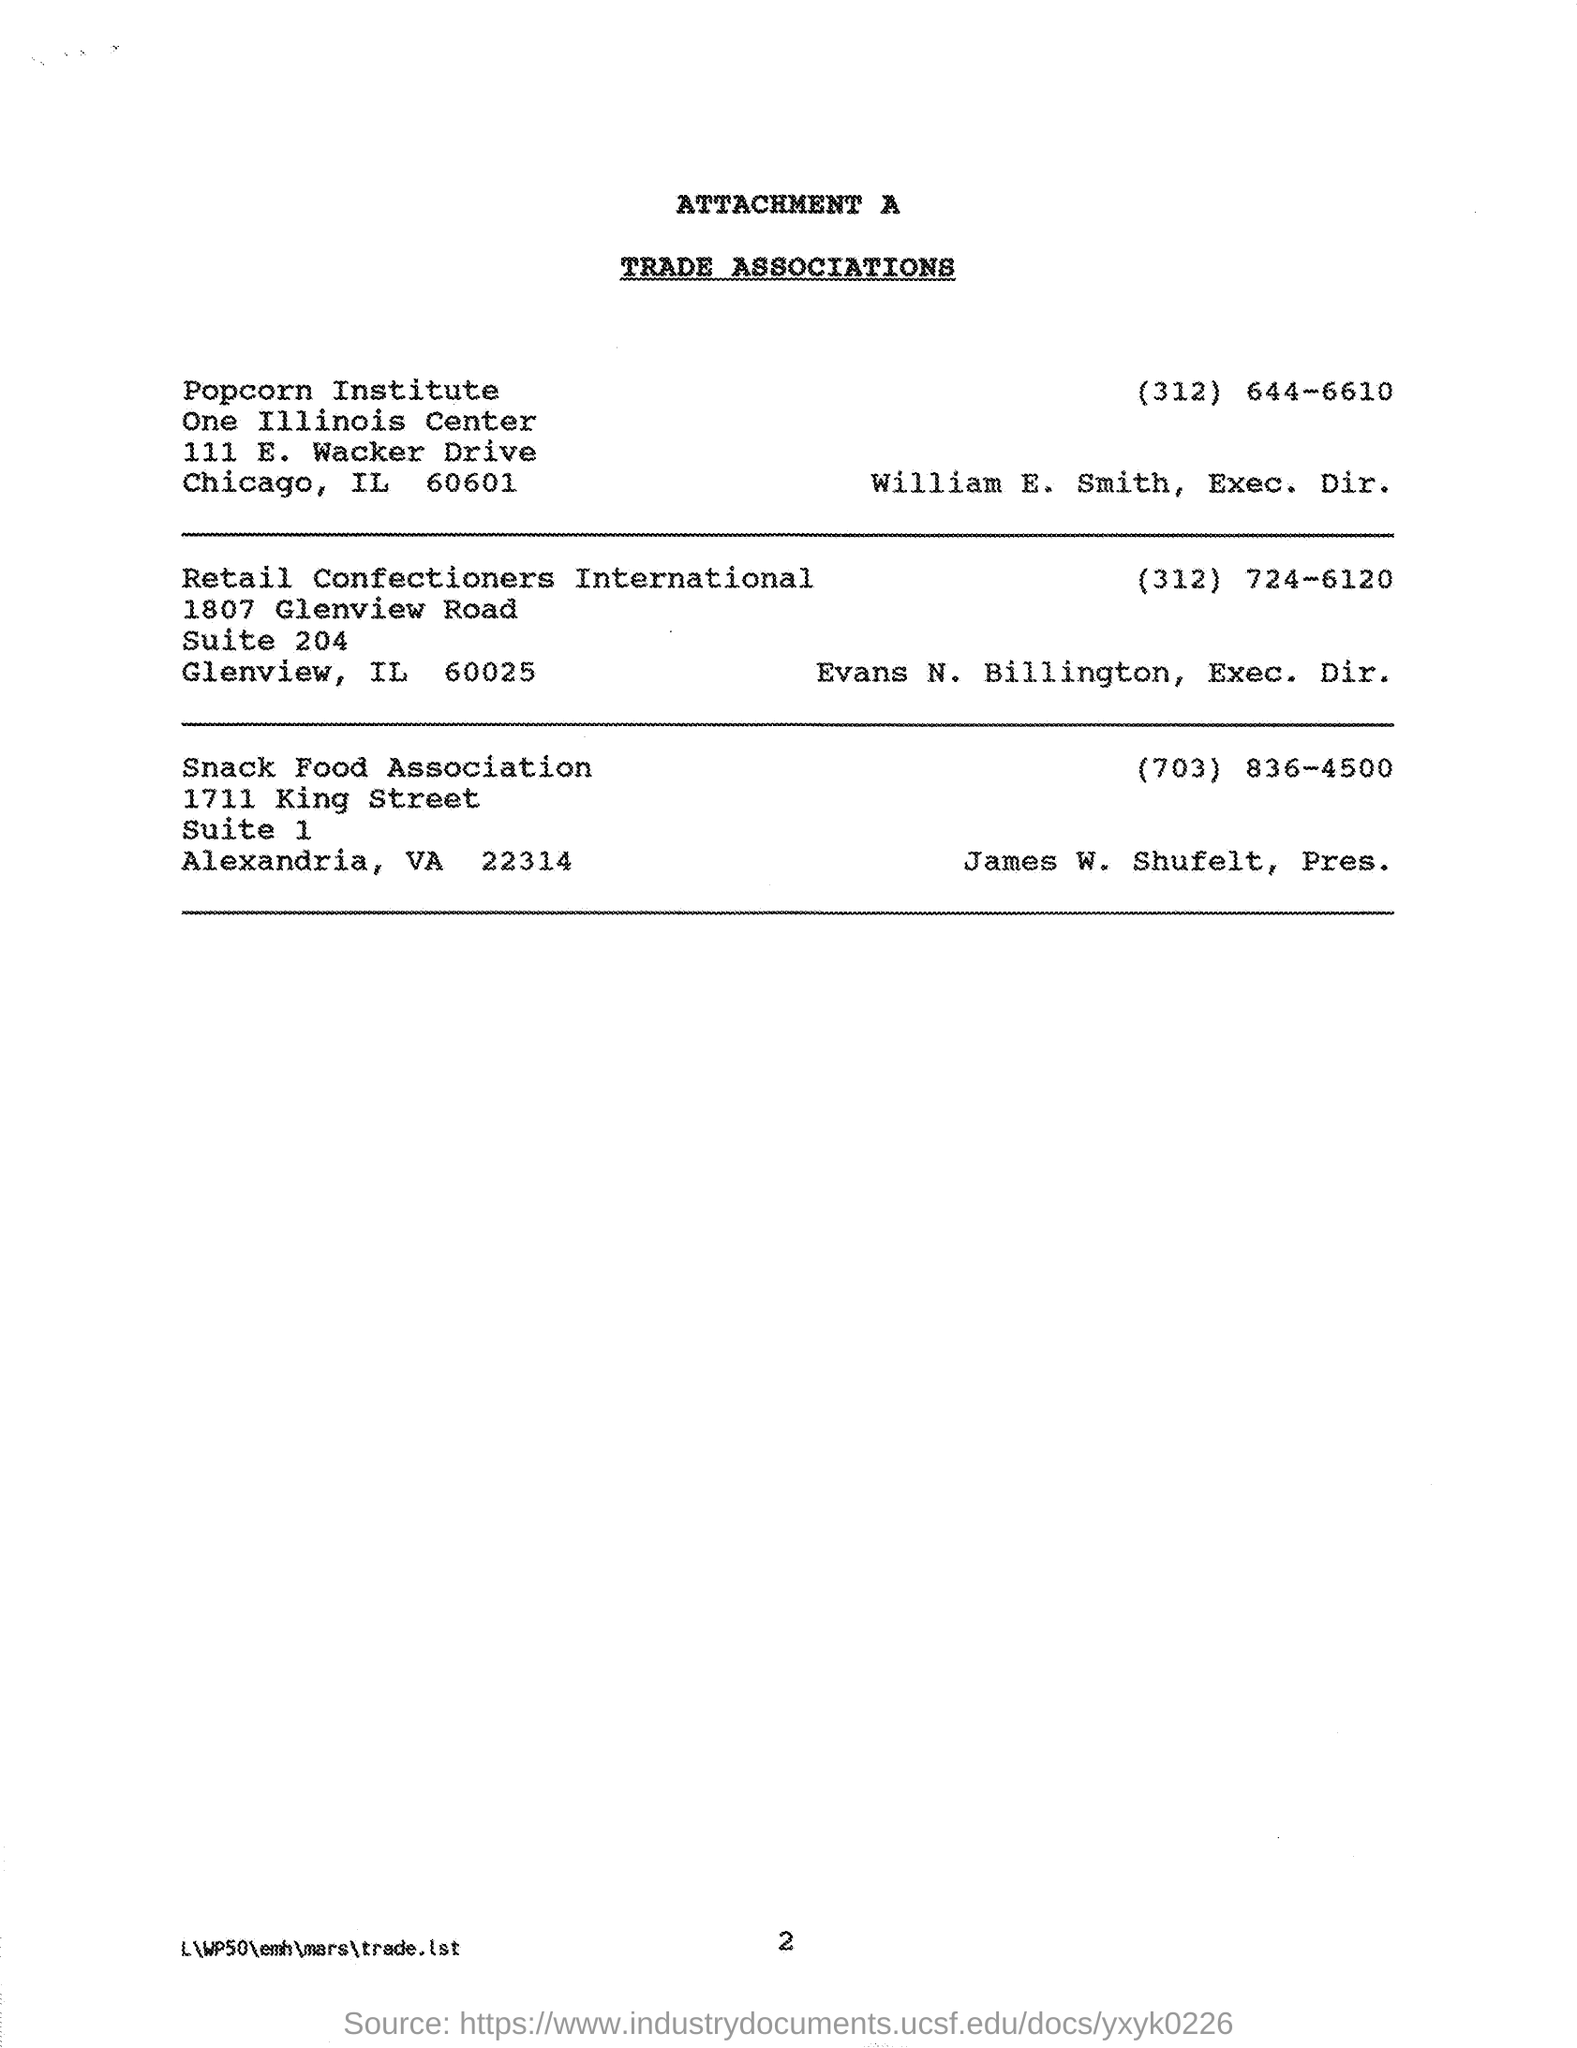Give some essential details in this illustration. James W. Shufelt is the president of the Snack Food Association. The executive director of the Popcorn Institute is William E. Smith. The executive director of Retail Confectioners International is Evans N. Billington. The number provided is for the Snack Food Association, and the phone number is (703) 836-4500. 